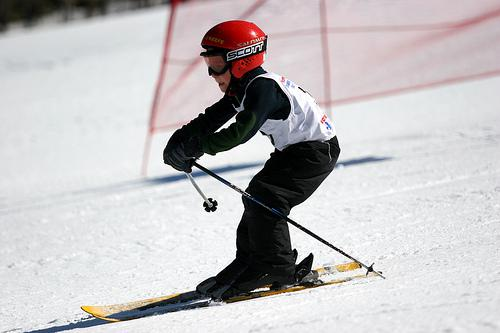Question: how many poles is the boy holding?
Choices:
A. 2.
B. 3.
C. 1.
D. 4.
Answer with the letter. Answer: A Question: what is written on the strap of the goggles?
Choices:
A. Steve.
B. SCOTT.
C. Roger.
D. Jamie.
Answer with the letter. Answer: B Question: where are the skier's arms positioned?
Choices:
A. Behind her.
B. Out to each side.
C. In front of him.
D. Up in the air.
Answer with the letter. Answer: C Question: what is on the skier's head?
Choices:
A. Snow.
B. A hat.
C. Helmet.
D. Hair.
Answer with the letter. Answer: C Question: what is the white substance beneath the skier's skis?
Choices:
A. Ice.
B. Snow.
C. Fake snow.
D. Slush.
Answer with the letter. Answer: B Question: what direction is the skier going?
Choices:
A. Uphill.
B. Northeast.
C. Southwest.
D. Downhill.
Answer with the letter. Answer: D 